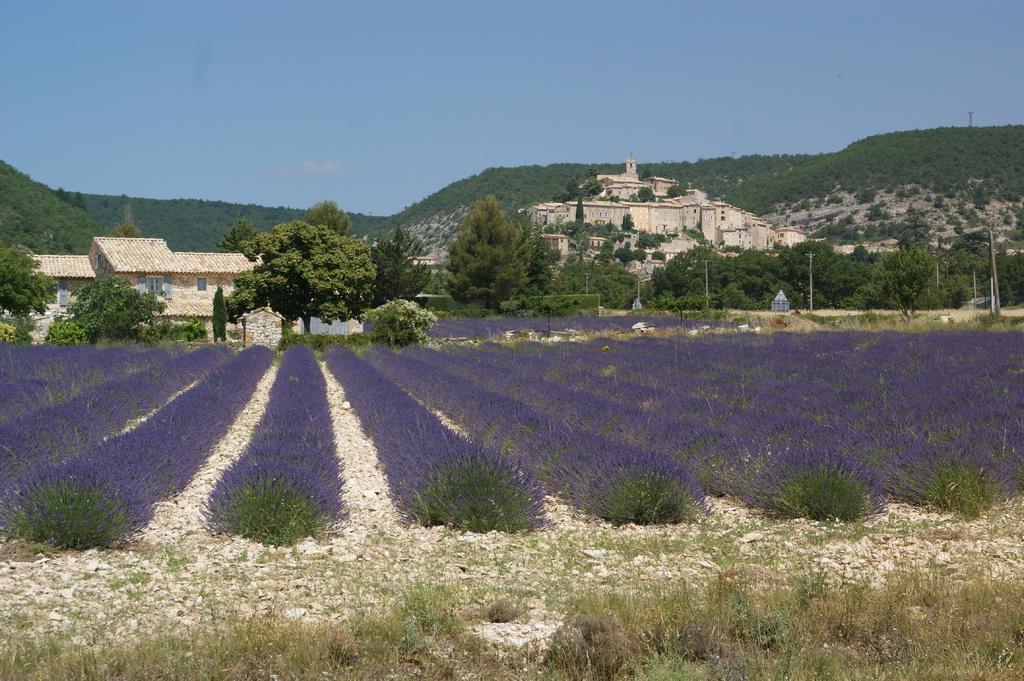Could you give a brief overview of what you see in this image? This picture is taken from the outside of the city. In this image, we can see some trees, plants with flowers which are in blue color. In the background, we can also see some houses, buildings, trees, plants, pole. At the top, we can see a sky, at the bottom, we can see some plants, grass and a land. 